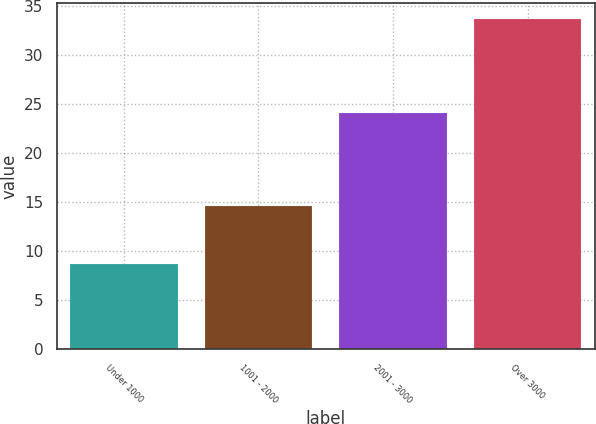Convert chart to OTSL. <chart><loc_0><loc_0><loc_500><loc_500><bar_chart><fcel>Under 1000<fcel>1001 - 2000<fcel>2001 - 3000<fcel>Over 3000<nl><fcel>8.65<fcel>14.65<fcel>24.1<fcel>33.62<nl></chart> 